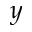<formula> <loc_0><loc_0><loc_500><loc_500>y</formula> 